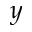<formula> <loc_0><loc_0><loc_500><loc_500>y</formula> 